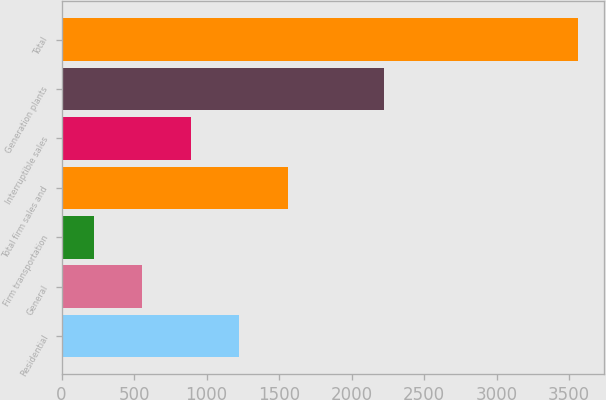Convert chart to OTSL. <chart><loc_0><loc_0><loc_500><loc_500><bar_chart><fcel>Residential<fcel>General<fcel>Firm transportation<fcel>Total firm sales and<fcel>Interruptible sales<fcel>Generation plants<fcel>Total<nl><fcel>1225<fcel>557<fcel>223<fcel>1559<fcel>891<fcel>2225<fcel>3563<nl></chart> 